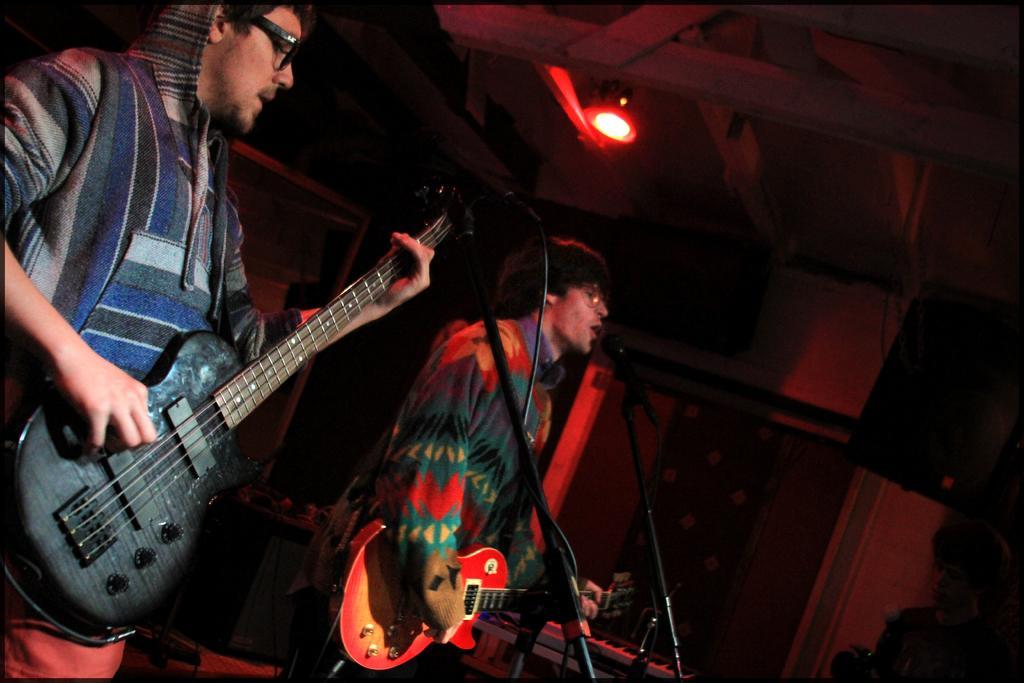How would you summarize this image in a sentence or two? In the image we can see there are two men who are standing and holding guitar in their hand and in front of them there is mic with a stand and on the top there is red colour light. 